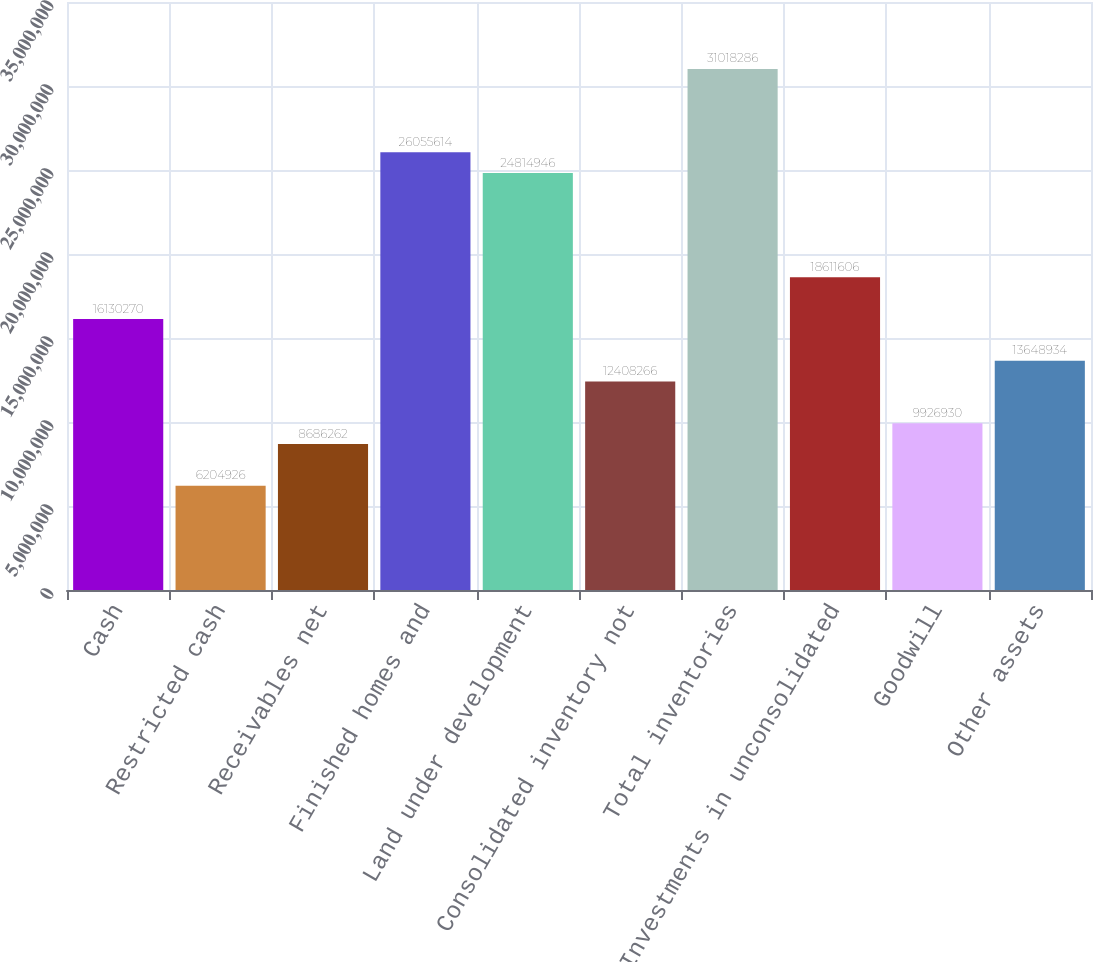Convert chart to OTSL. <chart><loc_0><loc_0><loc_500><loc_500><bar_chart><fcel>Cash<fcel>Restricted cash<fcel>Receivables net<fcel>Finished homes and<fcel>Land under development<fcel>Consolidated inventory not<fcel>Total inventories<fcel>Investments in unconsolidated<fcel>Goodwill<fcel>Other assets<nl><fcel>1.61303e+07<fcel>6.20493e+06<fcel>8.68626e+06<fcel>2.60556e+07<fcel>2.48149e+07<fcel>1.24083e+07<fcel>3.10183e+07<fcel>1.86116e+07<fcel>9.92693e+06<fcel>1.36489e+07<nl></chart> 